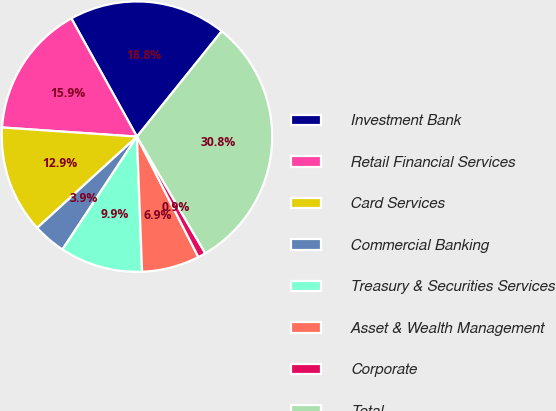<chart> <loc_0><loc_0><loc_500><loc_500><pie_chart><fcel>Investment Bank<fcel>Retail Financial Services<fcel>Card Services<fcel>Commercial Banking<fcel>Treasury & Securities Services<fcel>Asset & Wealth Management<fcel>Corporate<fcel>Total<nl><fcel>18.84%<fcel>15.86%<fcel>12.87%<fcel>3.92%<fcel>9.89%<fcel>6.9%<fcel>0.93%<fcel>30.78%<nl></chart> 